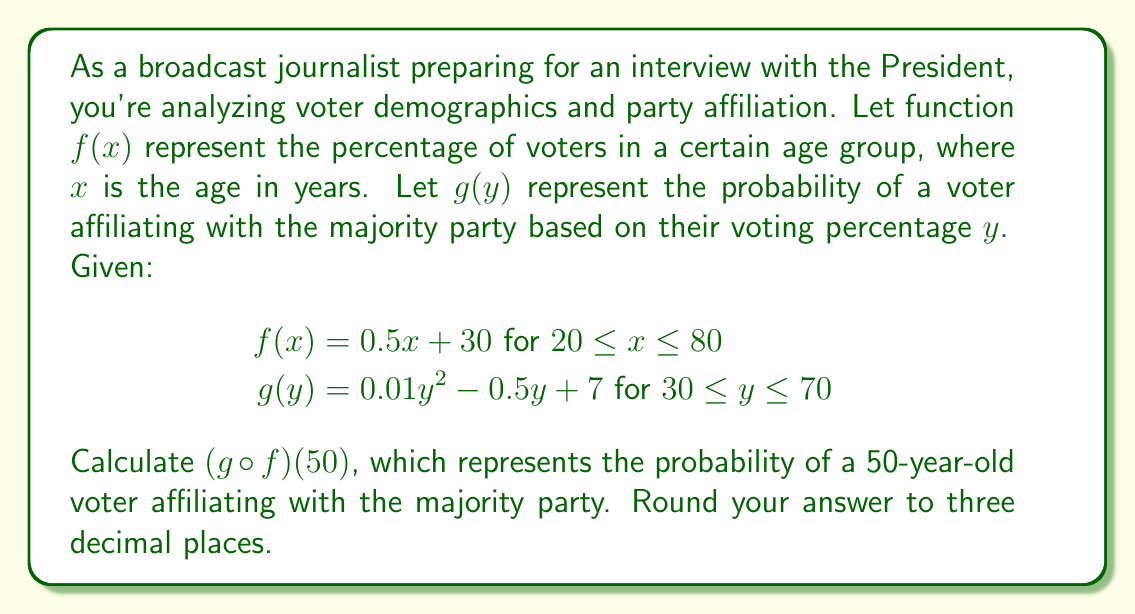What is the answer to this math problem? To solve this composite function problem, we need to follow these steps:

1) First, we need to find $f(50)$, as this will be the input for $g$.

   $f(50) = 0.5(50) + 30 = 25 + 30 = 55$

2) Now that we have $f(50) = 55$, we need to calculate $g(55)$.

3) We plug 55 into the function $g(y)$:

   $g(55) = 0.01(55)^2 - 0.5(55) + 7$

4) Let's calculate this step by step:
   
   $0.01(55)^2 = 0.01(3025) = 30.25$
   $-0.5(55) = -27.5$
   
   So, $g(55) = 30.25 - 27.5 + 7 = 9.75$

5) Therefore, $(g \circ f)(50) = g(f(50)) = g(55) = 9.75$

6) Rounding to three decimal places gives us 9.750.
Answer: 9.750 